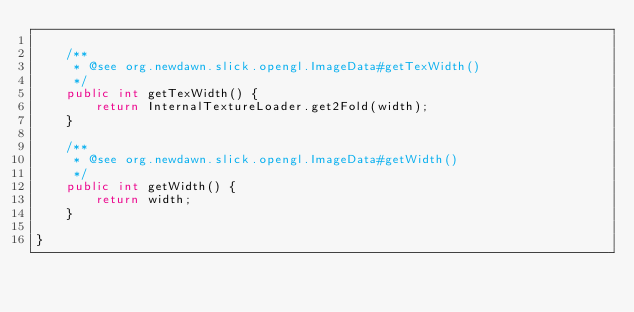<code> <loc_0><loc_0><loc_500><loc_500><_Java_>
	/**
	 * @see org.newdawn.slick.opengl.ImageData#getTexWidth()
	 */
	public int getTexWidth() {
		return InternalTextureLoader.get2Fold(width);
	}

	/**
	 * @see org.newdawn.slick.opengl.ImageData#getWidth()
	 */
	public int getWidth() {
		return width;
	}

}
</code> 